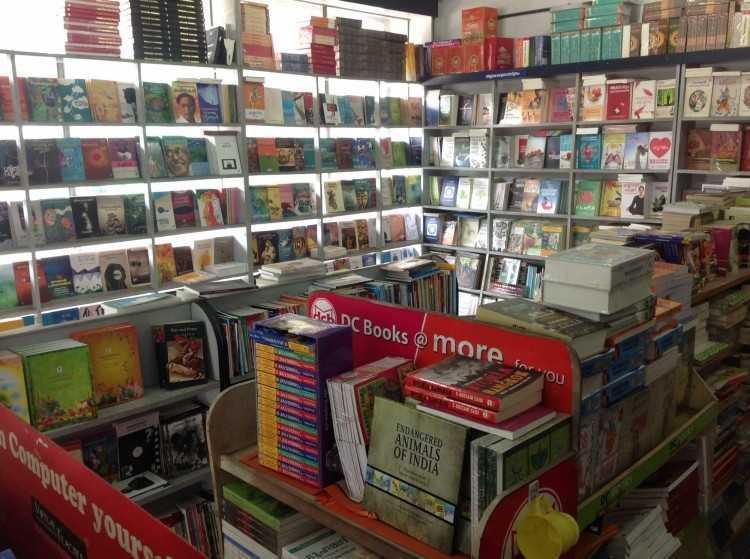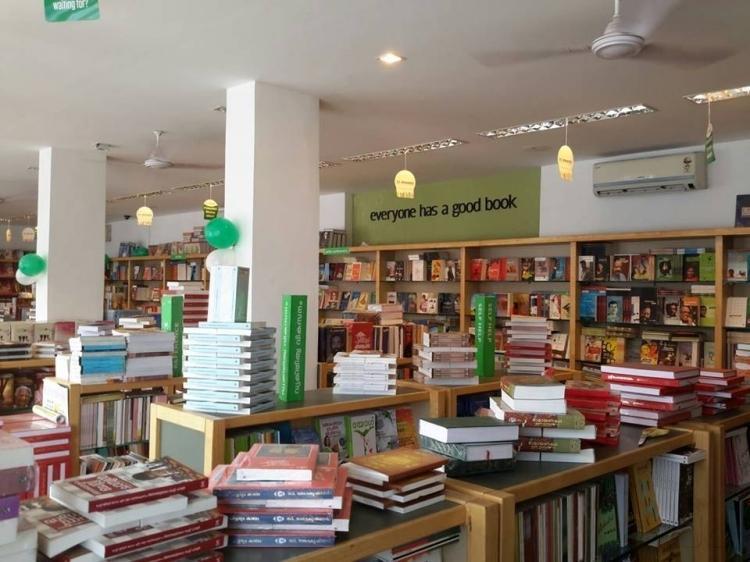The first image is the image on the left, the second image is the image on the right. Evaluate the accuracy of this statement regarding the images: "A bookstore image includes a green balloon and a variety of green signage.". Is it true? Answer yes or no. Yes. 